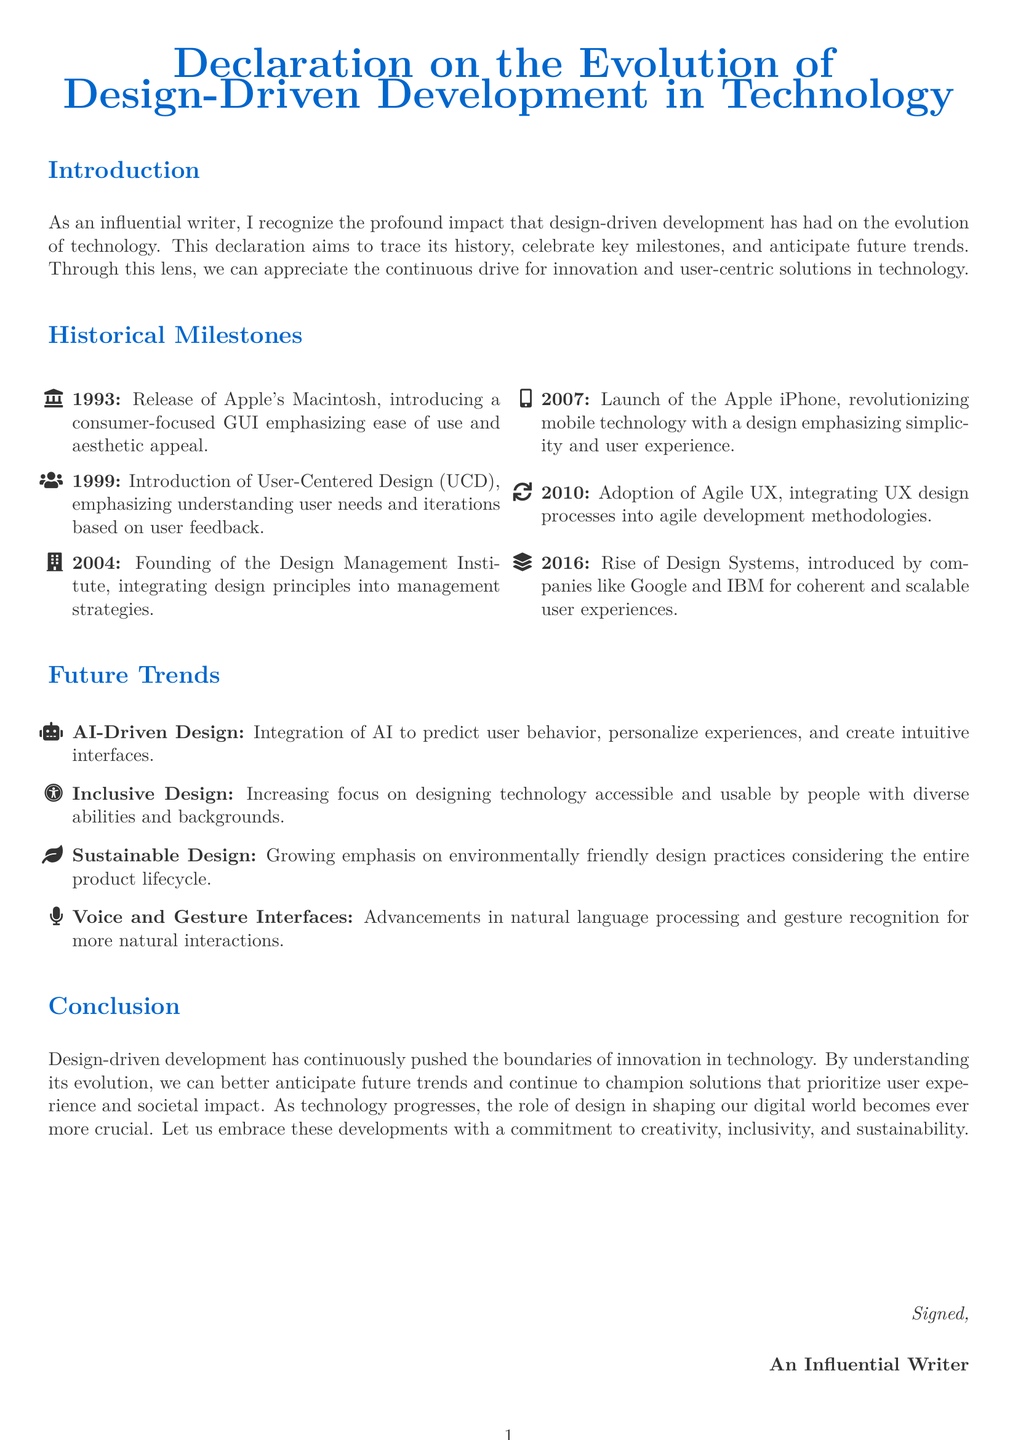What year was the Apple Macintosh released? The document states that the Apple Macintosh was released in 1993.
Answer: 1993 What design principle was introduced in 1999? The document mentions that User-Centered Design (UCD) was introduced in 1999.
Answer: User-Centered Design Which company launched the iPhone in 2007? According to the document, Apple launched the iPhone in 2007.
Answer: Apple What does AI-Driven Design aim to integrate? The document highlights that AI-Driven Design aims to integrate AI to predict user behavior.
Answer: AI What emphasis does the document place on sustainable design? The document indicates a growing emphasis on environmentally friendly design practices.
Answer: Environmentally friendly design practices What organization was founded in 2004? The document states that the Design Management Institute was founded in 2004.
Answer: Design Management Institute Which design methodology was adopted in 2010? The document mentions that Agile UX was adopted in 2010.
Answer: Agile UX What significant milestone occurred in 2016? The document notes the rise of Design Systems as a significant milestone in 2016.
Answer: Rise of Design Systems What is the purpose of inclusive design as mentioned? The document describes that inclusive design focuses on accessibility and usability for diverse abilities and backgrounds.
Answer: Accessibility and usability for diverse abilities and backgrounds 